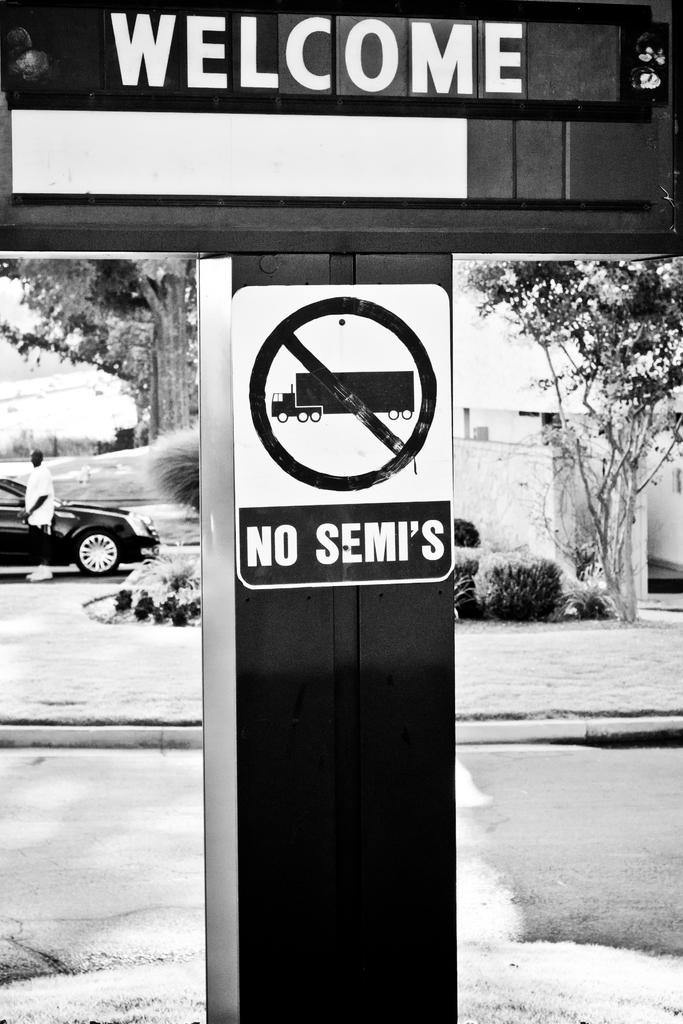What message is written on one of the objects in the image? There is an object with "welcome" written on it. What message is written on another object in the image? There is an object with "no semis" written on it. What does the toad smell like in the image? There is no toad present in the image, and therefore no such activity can be observed. 